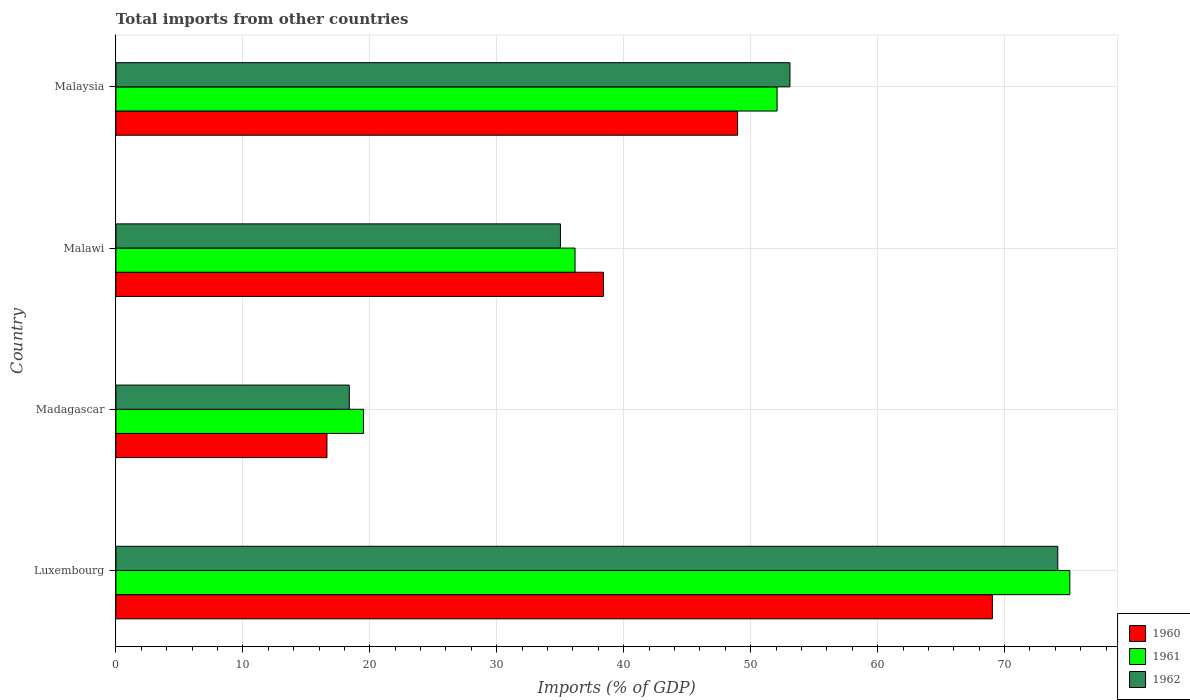Are the number of bars per tick equal to the number of legend labels?
Ensure brevity in your answer.  Yes. Are the number of bars on each tick of the Y-axis equal?
Keep it short and to the point. Yes. How many bars are there on the 3rd tick from the bottom?
Ensure brevity in your answer.  3. What is the label of the 3rd group of bars from the top?
Keep it short and to the point. Madagascar. What is the total imports in 1962 in Malawi?
Your answer should be very brief. 35.02. Across all countries, what is the maximum total imports in 1961?
Give a very brief answer. 75.14. Across all countries, what is the minimum total imports in 1962?
Make the answer very short. 18.38. In which country was the total imports in 1960 maximum?
Ensure brevity in your answer.  Luxembourg. In which country was the total imports in 1961 minimum?
Make the answer very short. Madagascar. What is the total total imports in 1961 in the graph?
Offer a terse response. 182.89. What is the difference between the total imports in 1960 in Malawi and that in Malaysia?
Offer a very short reply. -10.57. What is the difference between the total imports in 1962 in Malawi and the total imports in 1960 in Madagascar?
Provide a short and direct response. 18.39. What is the average total imports in 1961 per country?
Provide a succinct answer. 45.72. What is the difference between the total imports in 1960 and total imports in 1962 in Malawi?
Keep it short and to the point. 3.39. What is the ratio of the total imports in 1961 in Luxembourg to that in Malaysia?
Provide a short and direct response. 1.44. What is the difference between the highest and the second highest total imports in 1961?
Your response must be concise. 23.06. What is the difference between the highest and the lowest total imports in 1961?
Provide a succinct answer. 55.64. In how many countries, is the total imports in 1960 greater than the average total imports in 1960 taken over all countries?
Offer a terse response. 2. Is the sum of the total imports in 1962 in Luxembourg and Malaysia greater than the maximum total imports in 1960 across all countries?
Offer a terse response. Yes. What does the 3rd bar from the top in Madagascar represents?
Your response must be concise. 1960. What does the 2nd bar from the bottom in Madagascar represents?
Offer a terse response. 1961. How many countries are there in the graph?
Give a very brief answer. 4. Are the values on the major ticks of X-axis written in scientific E-notation?
Offer a very short reply. No. Does the graph contain grids?
Ensure brevity in your answer.  Yes. What is the title of the graph?
Keep it short and to the point. Total imports from other countries. Does "1973" appear as one of the legend labels in the graph?
Ensure brevity in your answer.  No. What is the label or title of the X-axis?
Your response must be concise. Imports (% of GDP). What is the label or title of the Y-axis?
Offer a very short reply. Country. What is the Imports (% of GDP) in 1960 in Luxembourg?
Keep it short and to the point. 69.04. What is the Imports (% of GDP) in 1961 in Luxembourg?
Provide a succinct answer. 75.14. What is the Imports (% of GDP) in 1962 in Luxembourg?
Your answer should be very brief. 74.19. What is the Imports (% of GDP) in 1960 in Madagascar?
Provide a succinct answer. 16.62. What is the Imports (% of GDP) in 1961 in Madagascar?
Your answer should be compact. 19.5. What is the Imports (% of GDP) in 1962 in Madagascar?
Your answer should be very brief. 18.38. What is the Imports (% of GDP) in 1960 in Malawi?
Keep it short and to the point. 38.4. What is the Imports (% of GDP) in 1961 in Malawi?
Your answer should be very brief. 36.17. What is the Imports (% of GDP) in 1962 in Malawi?
Offer a very short reply. 35.02. What is the Imports (% of GDP) in 1960 in Malaysia?
Provide a short and direct response. 48.97. What is the Imports (% of GDP) in 1961 in Malaysia?
Provide a succinct answer. 52.08. What is the Imports (% of GDP) in 1962 in Malaysia?
Ensure brevity in your answer.  53.09. Across all countries, what is the maximum Imports (% of GDP) in 1960?
Offer a very short reply. 69.04. Across all countries, what is the maximum Imports (% of GDP) in 1961?
Provide a succinct answer. 75.14. Across all countries, what is the maximum Imports (% of GDP) in 1962?
Keep it short and to the point. 74.19. Across all countries, what is the minimum Imports (% of GDP) of 1960?
Your response must be concise. 16.62. Across all countries, what is the minimum Imports (% of GDP) in 1961?
Ensure brevity in your answer.  19.5. Across all countries, what is the minimum Imports (% of GDP) in 1962?
Your answer should be compact. 18.38. What is the total Imports (% of GDP) in 1960 in the graph?
Your response must be concise. 173.03. What is the total Imports (% of GDP) of 1961 in the graph?
Make the answer very short. 182.89. What is the total Imports (% of GDP) in 1962 in the graph?
Offer a very short reply. 180.68. What is the difference between the Imports (% of GDP) of 1960 in Luxembourg and that in Madagascar?
Make the answer very short. 52.41. What is the difference between the Imports (% of GDP) of 1961 in Luxembourg and that in Madagascar?
Your answer should be very brief. 55.64. What is the difference between the Imports (% of GDP) of 1962 in Luxembourg and that in Madagascar?
Make the answer very short. 55.81. What is the difference between the Imports (% of GDP) in 1960 in Luxembourg and that in Malawi?
Offer a very short reply. 30.63. What is the difference between the Imports (% of GDP) in 1961 in Luxembourg and that in Malawi?
Provide a short and direct response. 38.97. What is the difference between the Imports (% of GDP) in 1962 in Luxembourg and that in Malawi?
Your answer should be very brief. 39.18. What is the difference between the Imports (% of GDP) in 1960 in Luxembourg and that in Malaysia?
Offer a very short reply. 20.07. What is the difference between the Imports (% of GDP) in 1961 in Luxembourg and that in Malaysia?
Keep it short and to the point. 23.06. What is the difference between the Imports (% of GDP) in 1962 in Luxembourg and that in Malaysia?
Give a very brief answer. 21.1. What is the difference between the Imports (% of GDP) of 1960 in Madagascar and that in Malawi?
Your response must be concise. -21.78. What is the difference between the Imports (% of GDP) in 1961 in Madagascar and that in Malawi?
Your answer should be very brief. -16.66. What is the difference between the Imports (% of GDP) of 1962 in Madagascar and that in Malawi?
Provide a short and direct response. -16.63. What is the difference between the Imports (% of GDP) in 1960 in Madagascar and that in Malaysia?
Give a very brief answer. -32.35. What is the difference between the Imports (% of GDP) of 1961 in Madagascar and that in Malaysia?
Provide a succinct answer. -32.58. What is the difference between the Imports (% of GDP) in 1962 in Madagascar and that in Malaysia?
Your answer should be compact. -34.71. What is the difference between the Imports (% of GDP) of 1960 in Malawi and that in Malaysia?
Make the answer very short. -10.57. What is the difference between the Imports (% of GDP) in 1961 in Malawi and that in Malaysia?
Keep it short and to the point. -15.91. What is the difference between the Imports (% of GDP) in 1962 in Malawi and that in Malaysia?
Provide a short and direct response. -18.08. What is the difference between the Imports (% of GDP) in 1960 in Luxembourg and the Imports (% of GDP) in 1961 in Madagascar?
Offer a terse response. 49.53. What is the difference between the Imports (% of GDP) in 1960 in Luxembourg and the Imports (% of GDP) in 1962 in Madagascar?
Make the answer very short. 50.65. What is the difference between the Imports (% of GDP) of 1961 in Luxembourg and the Imports (% of GDP) of 1962 in Madagascar?
Offer a terse response. 56.76. What is the difference between the Imports (% of GDP) of 1960 in Luxembourg and the Imports (% of GDP) of 1961 in Malawi?
Your answer should be compact. 32.87. What is the difference between the Imports (% of GDP) in 1960 in Luxembourg and the Imports (% of GDP) in 1962 in Malawi?
Offer a very short reply. 34.02. What is the difference between the Imports (% of GDP) in 1961 in Luxembourg and the Imports (% of GDP) in 1962 in Malawi?
Offer a terse response. 40.13. What is the difference between the Imports (% of GDP) of 1960 in Luxembourg and the Imports (% of GDP) of 1961 in Malaysia?
Your answer should be compact. 16.96. What is the difference between the Imports (% of GDP) in 1960 in Luxembourg and the Imports (% of GDP) in 1962 in Malaysia?
Offer a terse response. 15.94. What is the difference between the Imports (% of GDP) in 1961 in Luxembourg and the Imports (% of GDP) in 1962 in Malaysia?
Give a very brief answer. 22.05. What is the difference between the Imports (% of GDP) of 1960 in Madagascar and the Imports (% of GDP) of 1961 in Malawi?
Ensure brevity in your answer.  -19.54. What is the difference between the Imports (% of GDP) in 1960 in Madagascar and the Imports (% of GDP) in 1962 in Malawi?
Provide a short and direct response. -18.39. What is the difference between the Imports (% of GDP) of 1961 in Madagascar and the Imports (% of GDP) of 1962 in Malawi?
Your response must be concise. -15.51. What is the difference between the Imports (% of GDP) in 1960 in Madagascar and the Imports (% of GDP) in 1961 in Malaysia?
Give a very brief answer. -35.46. What is the difference between the Imports (% of GDP) in 1960 in Madagascar and the Imports (% of GDP) in 1962 in Malaysia?
Your response must be concise. -36.47. What is the difference between the Imports (% of GDP) in 1961 in Madagascar and the Imports (% of GDP) in 1962 in Malaysia?
Provide a short and direct response. -33.59. What is the difference between the Imports (% of GDP) of 1960 in Malawi and the Imports (% of GDP) of 1961 in Malaysia?
Offer a very short reply. -13.68. What is the difference between the Imports (% of GDP) of 1960 in Malawi and the Imports (% of GDP) of 1962 in Malaysia?
Give a very brief answer. -14.69. What is the difference between the Imports (% of GDP) in 1961 in Malawi and the Imports (% of GDP) in 1962 in Malaysia?
Your response must be concise. -16.93. What is the average Imports (% of GDP) in 1960 per country?
Provide a succinct answer. 43.26. What is the average Imports (% of GDP) of 1961 per country?
Offer a very short reply. 45.72. What is the average Imports (% of GDP) of 1962 per country?
Your answer should be very brief. 45.17. What is the difference between the Imports (% of GDP) of 1960 and Imports (% of GDP) of 1961 in Luxembourg?
Make the answer very short. -6.1. What is the difference between the Imports (% of GDP) in 1960 and Imports (% of GDP) in 1962 in Luxembourg?
Offer a terse response. -5.15. What is the difference between the Imports (% of GDP) of 1961 and Imports (% of GDP) of 1962 in Luxembourg?
Provide a short and direct response. 0.95. What is the difference between the Imports (% of GDP) of 1960 and Imports (% of GDP) of 1961 in Madagascar?
Give a very brief answer. -2.88. What is the difference between the Imports (% of GDP) of 1960 and Imports (% of GDP) of 1962 in Madagascar?
Your response must be concise. -1.76. What is the difference between the Imports (% of GDP) of 1961 and Imports (% of GDP) of 1962 in Madagascar?
Provide a short and direct response. 1.12. What is the difference between the Imports (% of GDP) of 1960 and Imports (% of GDP) of 1961 in Malawi?
Offer a terse response. 2.24. What is the difference between the Imports (% of GDP) of 1960 and Imports (% of GDP) of 1962 in Malawi?
Provide a succinct answer. 3.39. What is the difference between the Imports (% of GDP) in 1961 and Imports (% of GDP) in 1962 in Malawi?
Ensure brevity in your answer.  1.15. What is the difference between the Imports (% of GDP) of 1960 and Imports (% of GDP) of 1961 in Malaysia?
Your answer should be very brief. -3.11. What is the difference between the Imports (% of GDP) of 1960 and Imports (% of GDP) of 1962 in Malaysia?
Offer a terse response. -4.12. What is the difference between the Imports (% of GDP) in 1961 and Imports (% of GDP) in 1962 in Malaysia?
Keep it short and to the point. -1.01. What is the ratio of the Imports (% of GDP) in 1960 in Luxembourg to that in Madagascar?
Provide a succinct answer. 4.15. What is the ratio of the Imports (% of GDP) of 1961 in Luxembourg to that in Madagascar?
Provide a short and direct response. 3.85. What is the ratio of the Imports (% of GDP) in 1962 in Luxembourg to that in Madagascar?
Ensure brevity in your answer.  4.04. What is the ratio of the Imports (% of GDP) in 1960 in Luxembourg to that in Malawi?
Make the answer very short. 1.8. What is the ratio of the Imports (% of GDP) of 1961 in Luxembourg to that in Malawi?
Provide a succinct answer. 2.08. What is the ratio of the Imports (% of GDP) of 1962 in Luxembourg to that in Malawi?
Offer a terse response. 2.12. What is the ratio of the Imports (% of GDP) in 1960 in Luxembourg to that in Malaysia?
Ensure brevity in your answer.  1.41. What is the ratio of the Imports (% of GDP) of 1961 in Luxembourg to that in Malaysia?
Keep it short and to the point. 1.44. What is the ratio of the Imports (% of GDP) of 1962 in Luxembourg to that in Malaysia?
Provide a short and direct response. 1.4. What is the ratio of the Imports (% of GDP) in 1960 in Madagascar to that in Malawi?
Keep it short and to the point. 0.43. What is the ratio of the Imports (% of GDP) of 1961 in Madagascar to that in Malawi?
Provide a succinct answer. 0.54. What is the ratio of the Imports (% of GDP) in 1962 in Madagascar to that in Malawi?
Your response must be concise. 0.53. What is the ratio of the Imports (% of GDP) in 1960 in Madagascar to that in Malaysia?
Provide a short and direct response. 0.34. What is the ratio of the Imports (% of GDP) in 1961 in Madagascar to that in Malaysia?
Offer a very short reply. 0.37. What is the ratio of the Imports (% of GDP) in 1962 in Madagascar to that in Malaysia?
Make the answer very short. 0.35. What is the ratio of the Imports (% of GDP) of 1960 in Malawi to that in Malaysia?
Provide a succinct answer. 0.78. What is the ratio of the Imports (% of GDP) in 1961 in Malawi to that in Malaysia?
Offer a terse response. 0.69. What is the ratio of the Imports (% of GDP) in 1962 in Malawi to that in Malaysia?
Ensure brevity in your answer.  0.66. What is the difference between the highest and the second highest Imports (% of GDP) of 1960?
Offer a terse response. 20.07. What is the difference between the highest and the second highest Imports (% of GDP) in 1961?
Your response must be concise. 23.06. What is the difference between the highest and the second highest Imports (% of GDP) of 1962?
Provide a succinct answer. 21.1. What is the difference between the highest and the lowest Imports (% of GDP) in 1960?
Offer a terse response. 52.41. What is the difference between the highest and the lowest Imports (% of GDP) in 1961?
Your answer should be very brief. 55.64. What is the difference between the highest and the lowest Imports (% of GDP) in 1962?
Provide a succinct answer. 55.81. 